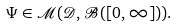<formula> <loc_0><loc_0><loc_500><loc_500>\Psi \in \mathcal { M } ( \mathcal { D } , \mathcal { B } ( [ 0 , \infty ] ) ) .</formula> 